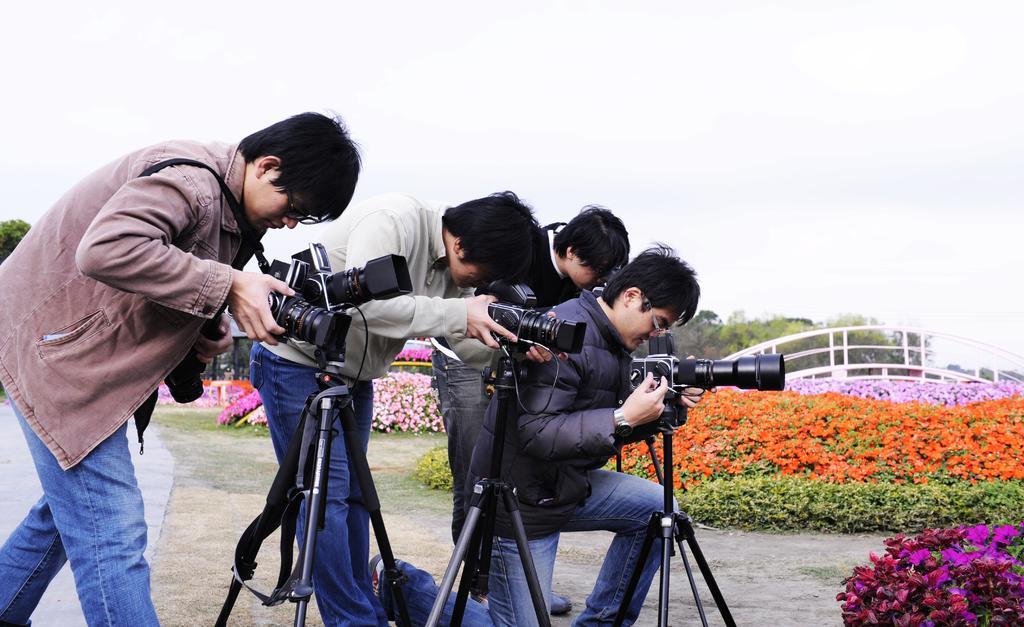In one or two sentences, can you explain what this image depicts? In this picture, we can see a few people holding some objects, we can see the ground with some objects like camera stand, and we can see some plants, flowers, bridge, trees and the sky. 